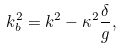<formula> <loc_0><loc_0><loc_500><loc_500>k ^ { 2 } _ { b } = k ^ { 2 } - \kappa ^ { 2 } \frac { \delta } { g } ,</formula> 